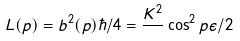Convert formula to latex. <formula><loc_0><loc_0><loc_500><loc_500>L ( p ) = b ^ { 2 } ( p ) \hbar { / } 4 = \frac { K ^ { 2 } } { } \cos ^ { 2 } { p \epsilon / 2 }</formula> 